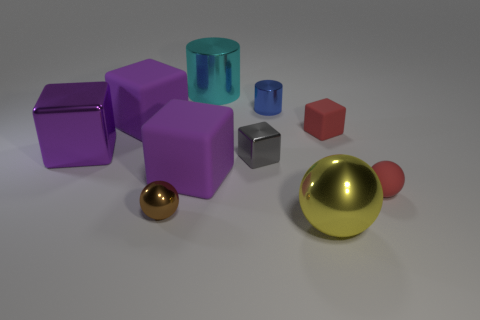What is the size of the sphere that is the same color as the small rubber block?
Make the answer very short. Small. There is a ball that is left of the small metallic object behind the block right of the big shiny sphere; what is its color?
Your answer should be very brief. Brown. There is a large shiny thing that is the same shape as the tiny brown object; what is its color?
Your answer should be compact. Yellow. Are there any other things that are the same color as the small cylinder?
Offer a very short reply. No. How many other objects are there of the same material as the tiny red sphere?
Your response must be concise. 3. What size is the cyan cylinder?
Provide a succinct answer. Large. Are there any tiny red things of the same shape as the large yellow metallic object?
Keep it short and to the point. Yes. What number of objects are either brown spheres or small things that are on the left side of the big yellow object?
Ensure brevity in your answer.  3. What color is the small thing to the left of the cyan shiny thing?
Offer a terse response. Brown. There is a purple rubber cube that is in front of the tiny gray thing; does it have the same size as the blue shiny object behind the gray block?
Your answer should be compact. No. 